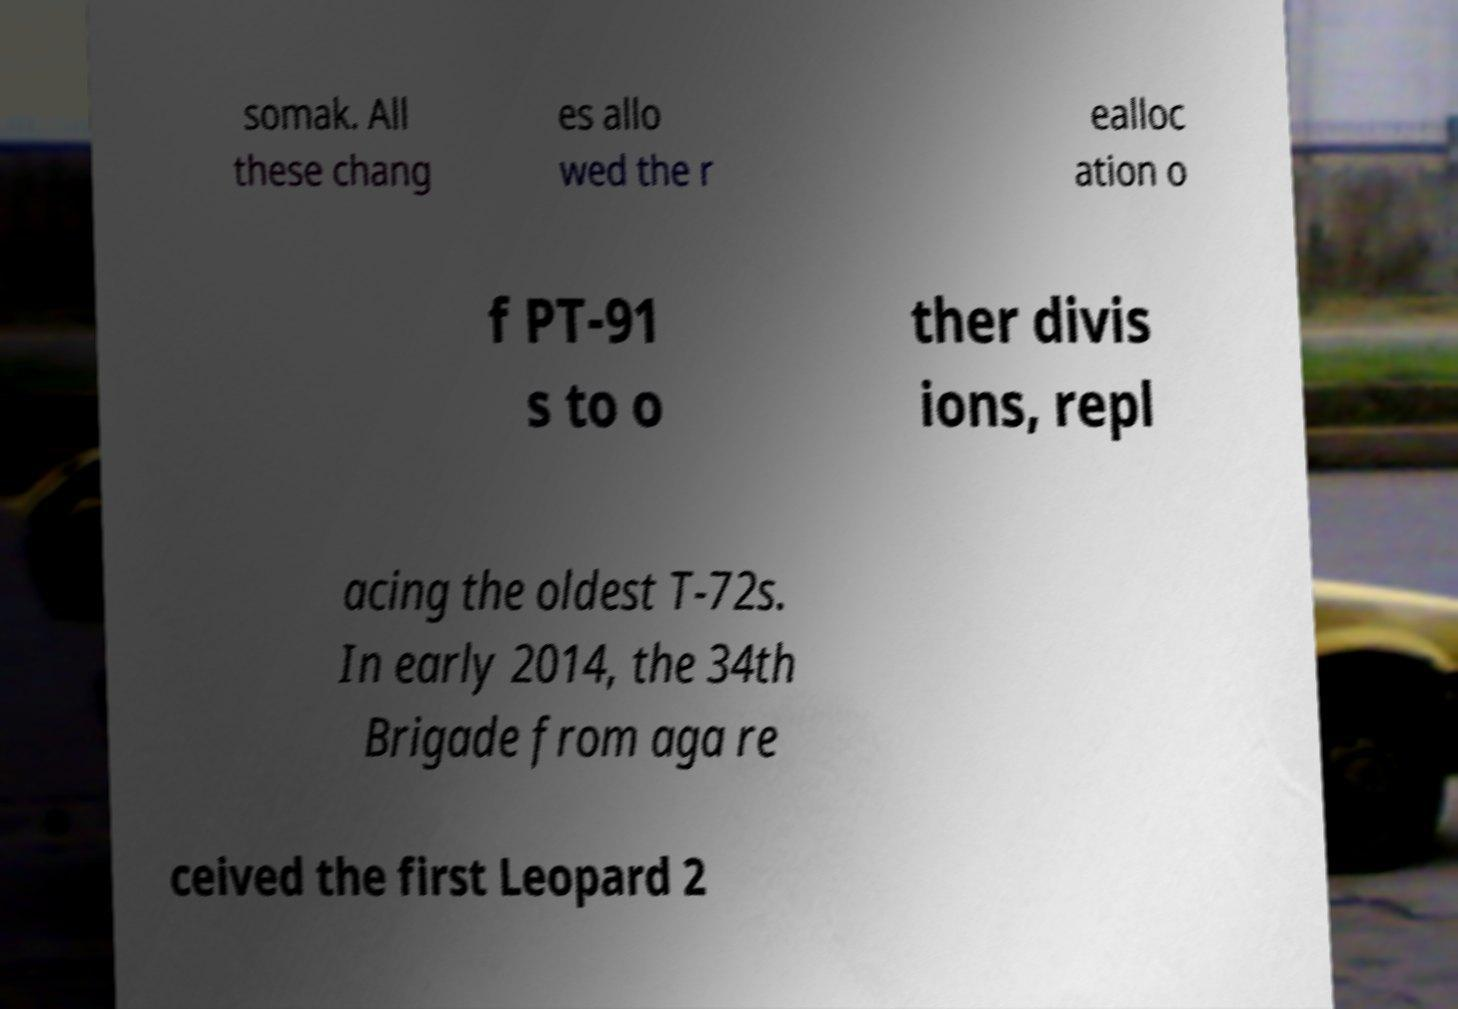Please read and relay the text visible in this image. What does it say? somak. All these chang es allo wed the r ealloc ation o f PT-91 s to o ther divis ions, repl acing the oldest T-72s. In early 2014, the 34th Brigade from aga re ceived the first Leopard 2 